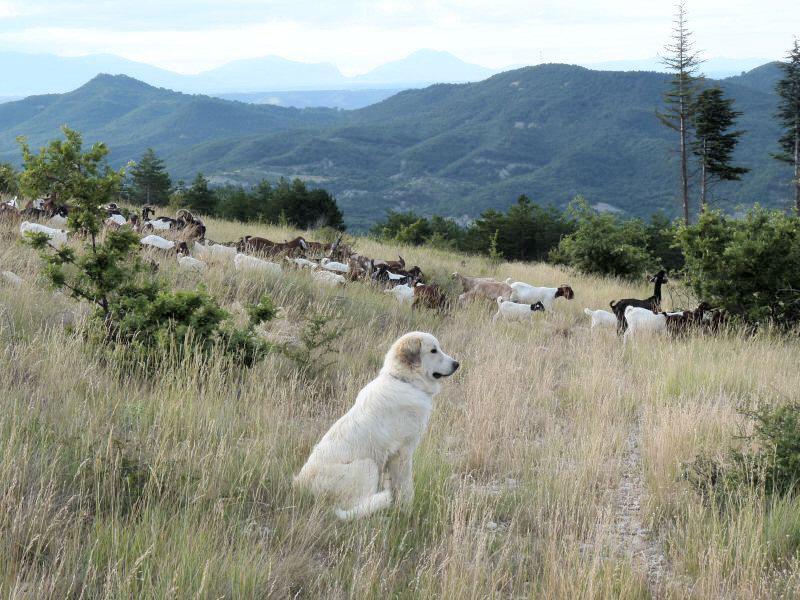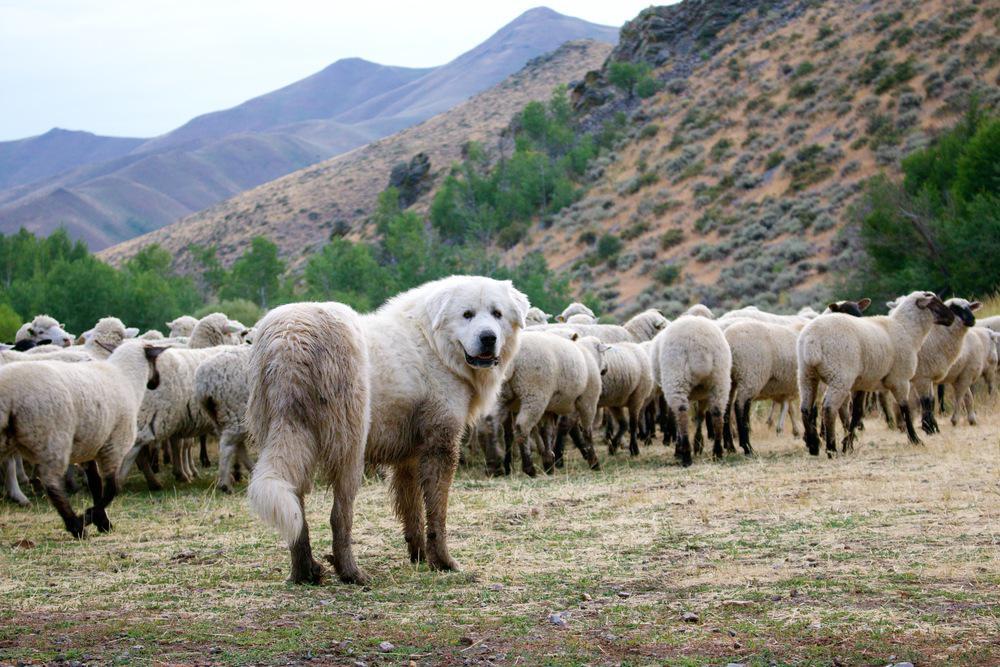The first image is the image on the left, the second image is the image on the right. For the images shown, is this caption "Both images have a fluffy dog with one or more sheep." true? Answer yes or no. Yes. The first image is the image on the left, the second image is the image on the right. Considering the images on both sides, is "A dog is right next to a sheep in at least one of the images." valid? Answer yes or no. No. 